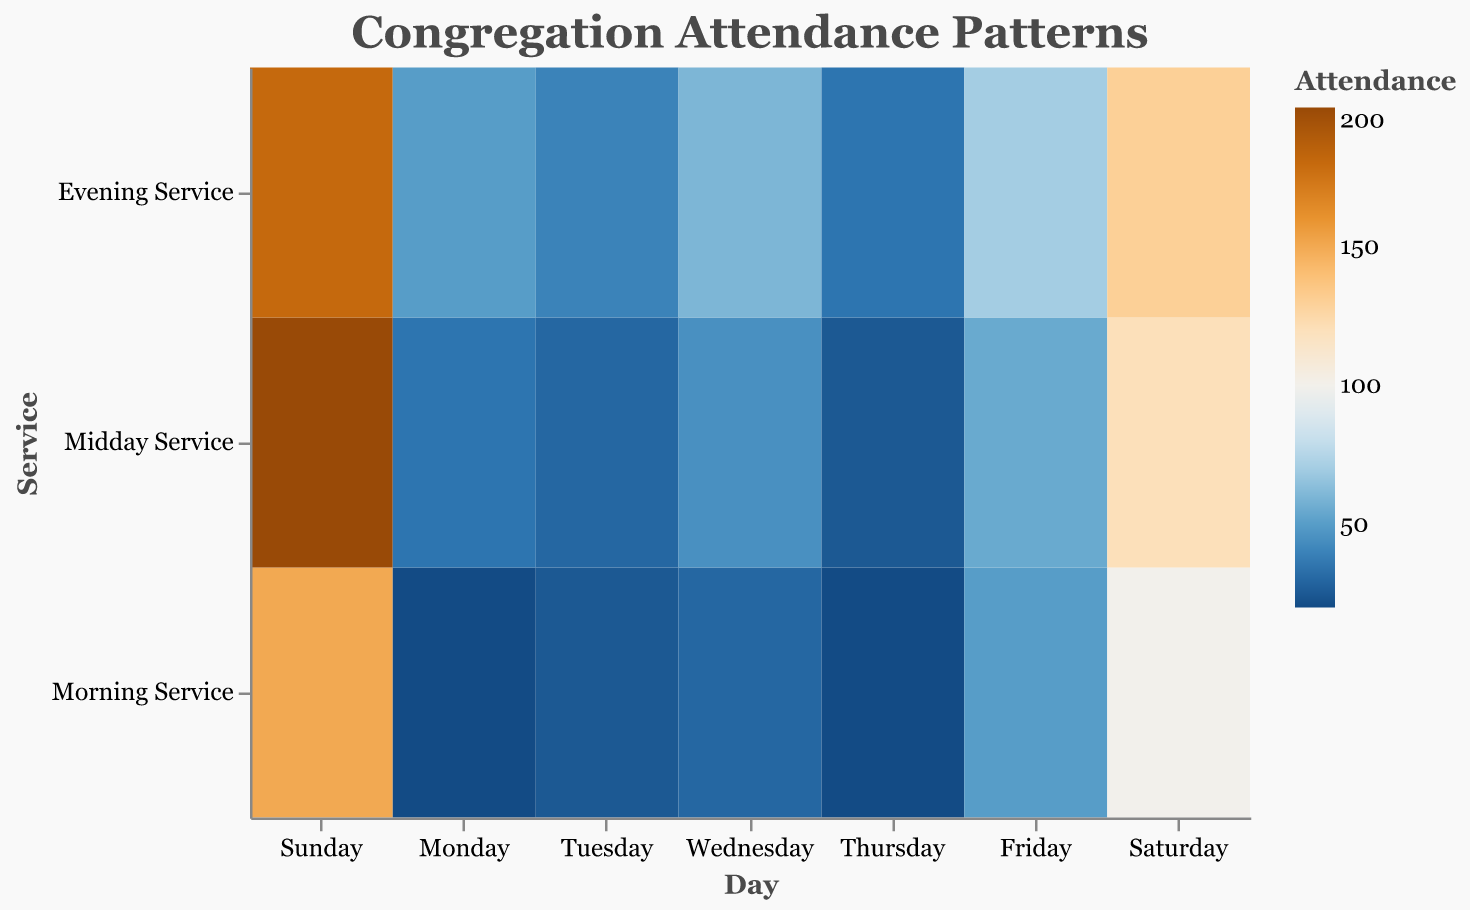What's the title of the figure? The title of the figure is typically found at the top and helps provide context for what the visualization is about. Here it is labeled "Congregation Attendance Patterns".
Answer: Congregation Attendance Patterns On which day is the Evening Service attendance the highest? To find this, you need to look at the color intensity in the row labeled "Evening Service" and identify which day has the most intense color. The highest Evening Service attendance occurs on Sunday, marked by the orange color indicating a high number (180).
Answer: Sunday Which service has the lowest attendance on Monday? By examining the Monday column, find the service with the lightest color. This indicates the lowest attendance. The lightest color in the Monday column represents the Morning Service with 20 attendees.
Answer: Morning Service What is the average attendance for services on Wednesday? Add the attendance numbers for all services on Wednesday: 30 (Morning) + 45 (Midday) + 60 (Evening), and then divide by the number of services (3). This calculation yields (30 + 45 + 60) / 3 = 45.
Answer: 45 Compare the Morning Services' attendance on Saturday and Tuesday. Which day experienced greater attendance and by how much? Look at the Morning Service row and compare the values for Saturday (100) and Tuesday (25). Subtract the smaller number from the larger one to find the difference: 100 - 25 = 75. Saturday had 75 more attendees.
Answer: Saturday by 75 What is the total attendance for all services on Sunday? Add the attendance numbers for all services on Sunday: 150 (Morning) + 200 (Midday) + 180 (Evening). The total attendance is 150 + 200 + 180 = 530.
Answer: 530 Identify the day with the most attendees for the Midday Service? By looking at the Midday Service row, find the day with the most intense color, which is Sunday with 200 attendees.
Answer: Sunday How does the attendance for Friday's Evening Service compare to Thursday's Evening Service? Compare the attendance numbers provided for both days in the Evening Service row: Friday has 70 attendees while Thursday has 35. Therefore, Friday has 35 more attendees than Thursday.
Answer: Friday has 35 more Calculate the range of attendance numbers for Saturday's services. Identify the highest and lowest attendance numbers for Saturday: 130 (Evening) and 100 (Morning). Subtract the smallest from the largest to find the range: 130 - 100 = 30.
Answer: 30 Which service day and type have the lowest overall attendance and what is the number? Look for the lightest colored square across the entire heatmap. The lightest square represents Monday Morning Service with an attendance of 20.
Answer: Monday Morning Service with 20 